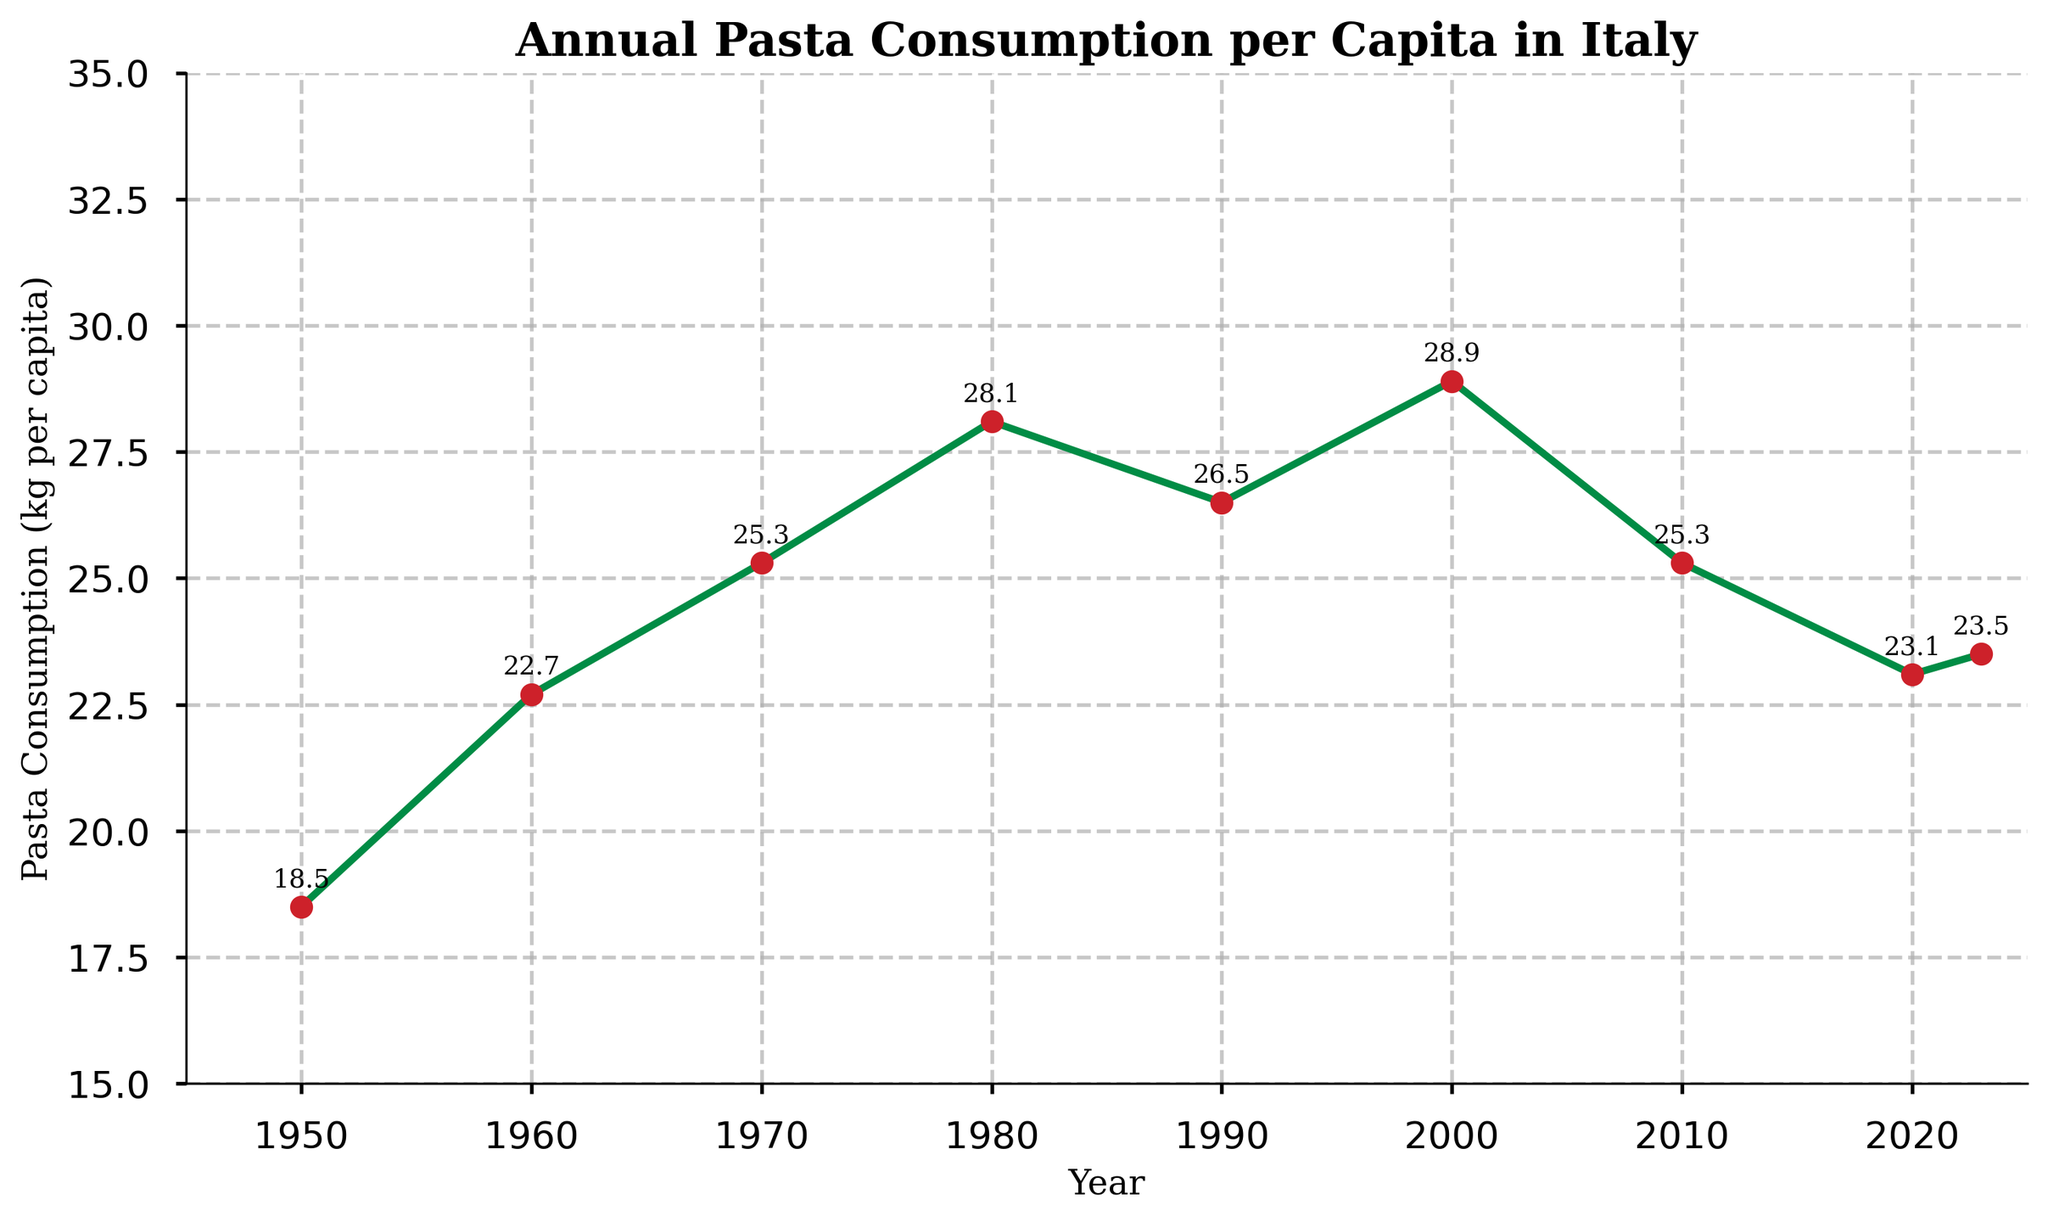What was the highest annual pasta consumption per capita in Italy? Look at the y-axis for the highest point on the line, which occurs in 2000 with a consumption of 28.9 kg per capita.
Answer: 28.9 kg During which year did pasta consumption per capita show the second highest point? Identify the second highest peak on the y-axis. The highest is in 2000, and the second highest is in 1980 with a consumption of 28.1 kg per capita.
Answer: 1980 What is the overall trend of pasta consumption per capita in Italy from 2000 to 2023? Observe the line graph from 2000 to 2023. The line generally trends downward from 28.9 kg in 2000 to 23.5 kg in 2023.
Answer: Downward In which decade did pasta consumption per capita first exceed 25 kg? Look at the data points from 1950 up to 2023 and identify the decade in which pasta consumption per capita first surpasses 25 kg. This occurs in the 1970s where it reached 25.3 kg.
Answer: 1970s How much did pasta consumption per capita decline from 1980 to 1990? Calculate the difference between consumption in 1980 (28.1 kg) and 1990 (26.5 kg): 28.1 kg - 26.5 kg = 1.6 kg.
Answer: 1.6 kg Is the pasta consumption per capita in 2023 higher, lower, or equal to that in 2020? Compare the y-values for the years 2020 (23.1 kg) and 2023 (23.5 kg).
Answer: Higher How many times did pasta consumption per capita peak above 25 kg? Identify each data point that exceeds 25 kg: 1970, 1980, 1990, and 2000.
Answer: 4 times 